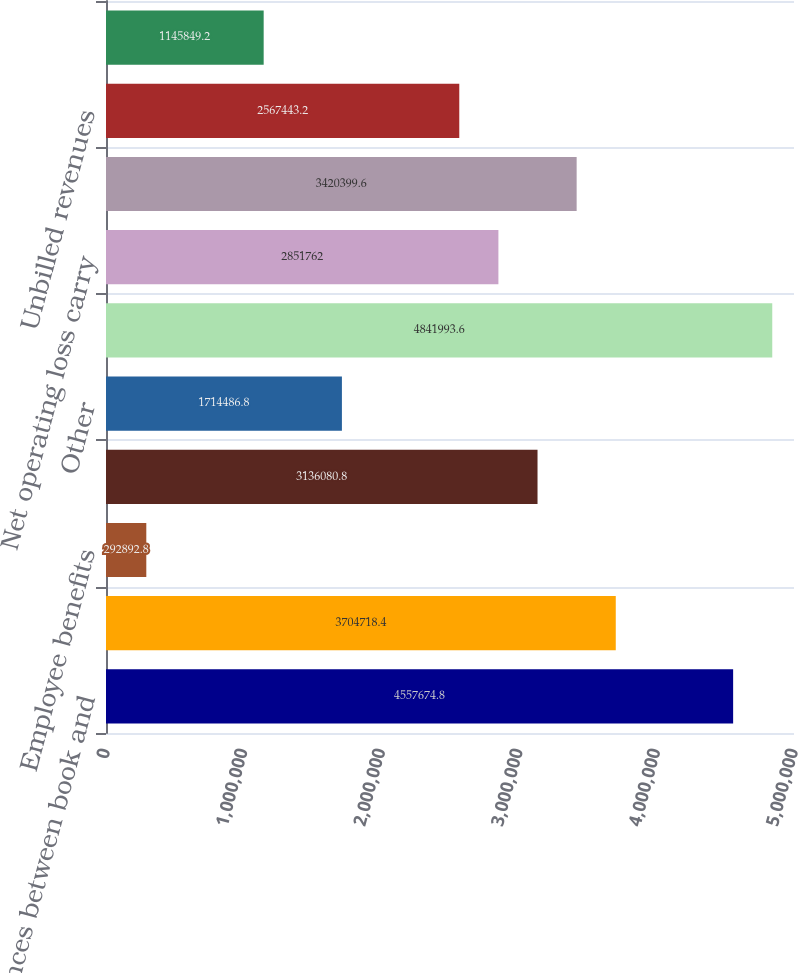Convert chart. <chart><loc_0><loc_0><loc_500><loc_500><bar_chart><fcel>Differences between book and<fcel>Regulatory assets<fcel>Employee benefits<fcel>Deferred costs<fcel>Other<fcel>Total deferred tax liabilities<fcel>Net operating loss carry<fcel>Tax credit carry forward<fcel>Unbilled revenues<fcel>Other comprehensive income<nl><fcel>4.55767e+06<fcel>3.70472e+06<fcel>292893<fcel>3.13608e+06<fcel>1.71449e+06<fcel>4.84199e+06<fcel>2.85176e+06<fcel>3.4204e+06<fcel>2.56744e+06<fcel>1.14585e+06<nl></chart> 